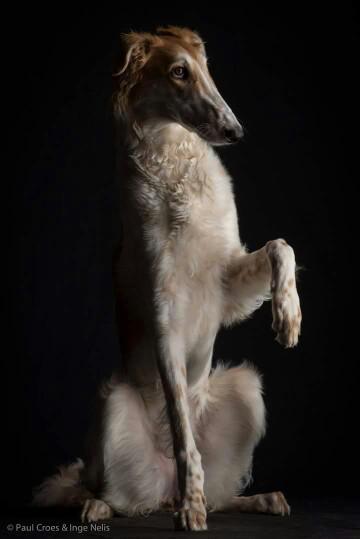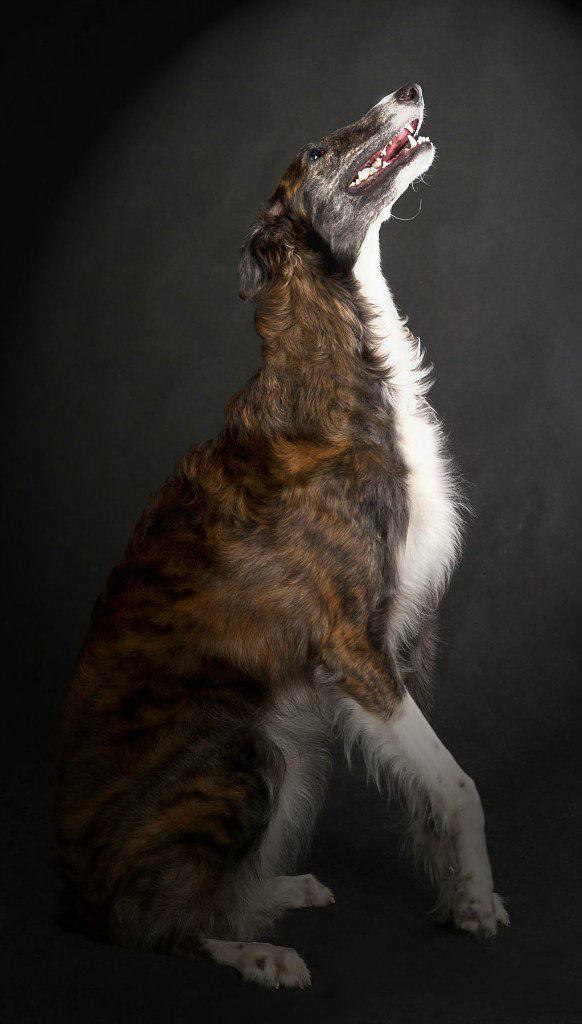The first image is the image on the left, the second image is the image on the right. Assess this claim about the two images: "the left and right image contains the same number of dogs.". Correct or not? Answer yes or no. Yes. 